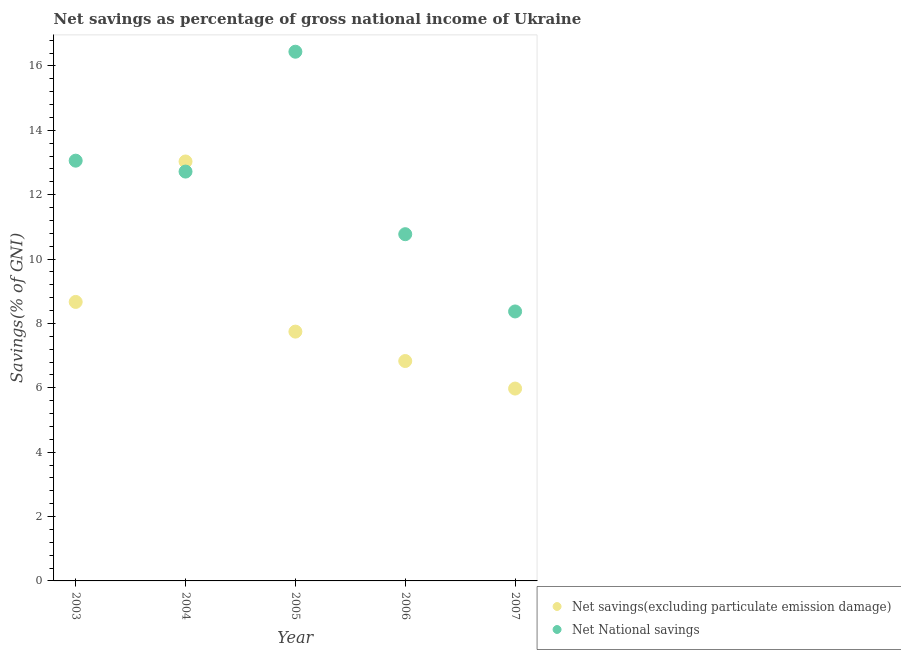How many different coloured dotlines are there?
Keep it short and to the point. 2. What is the net national savings in 2003?
Offer a very short reply. 13.06. Across all years, what is the maximum net savings(excluding particulate emission damage)?
Make the answer very short. 13.03. Across all years, what is the minimum net savings(excluding particulate emission damage)?
Provide a succinct answer. 5.98. What is the total net national savings in the graph?
Make the answer very short. 61.37. What is the difference between the net national savings in 2003 and that in 2006?
Keep it short and to the point. 2.28. What is the difference between the net savings(excluding particulate emission damage) in 2007 and the net national savings in 2005?
Offer a terse response. -10.47. What is the average net savings(excluding particulate emission damage) per year?
Your answer should be very brief. 8.45. In the year 2003, what is the difference between the net national savings and net savings(excluding particulate emission damage)?
Ensure brevity in your answer.  4.39. What is the ratio of the net savings(excluding particulate emission damage) in 2005 to that in 2006?
Ensure brevity in your answer.  1.13. Is the net savings(excluding particulate emission damage) in 2005 less than that in 2006?
Your answer should be very brief. No. Is the difference between the net savings(excluding particulate emission damage) in 2005 and 2007 greater than the difference between the net national savings in 2005 and 2007?
Ensure brevity in your answer.  No. What is the difference between the highest and the second highest net savings(excluding particulate emission damage)?
Your answer should be very brief. 4.36. What is the difference between the highest and the lowest net savings(excluding particulate emission damage)?
Ensure brevity in your answer.  7.06. In how many years, is the net savings(excluding particulate emission damage) greater than the average net savings(excluding particulate emission damage) taken over all years?
Give a very brief answer. 2. Is the net savings(excluding particulate emission damage) strictly less than the net national savings over the years?
Your response must be concise. No. How many dotlines are there?
Your response must be concise. 2. What is the difference between two consecutive major ticks on the Y-axis?
Your response must be concise. 2. Are the values on the major ticks of Y-axis written in scientific E-notation?
Offer a very short reply. No. Does the graph contain any zero values?
Offer a terse response. No. How are the legend labels stacked?
Offer a very short reply. Vertical. What is the title of the graph?
Offer a terse response. Net savings as percentage of gross national income of Ukraine. Does "Female entrants" appear as one of the legend labels in the graph?
Your answer should be compact. No. What is the label or title of the Y-axis?
Your answer should be compact. Savings(% of GNI). What is the Savings(% of GNI) of Net savings(excluding particulate emission damage) in 2003?
Ensure brevity in your answer.  8.67. What is the Savings(% of GNI) of Net National savings in 2003?
Make the answer very short. 13.06. What is the Savings(% of GNI) of Net savings(excluding particulate emission damage) in 2004?
Your answer should be very brief. 13.03. What is the Savings(% of GNI) in Net National savings in 2004?
Your answer should be compact. 12.72. What is the Savings(% of GNI) of Net savings(excluding particulate emission damage) in 2005?
Your answer should be very brief. 7.75. What is the Savings(% of GNI) of Net National savings in 2005?
Provide a succinct answer. 16.44. What is the Savings(% of GNI) in Net savings(excluding particulate emission damage) in 2006?
Ensure brevity in your answer.  6.83. What is the Savings(% of GNI) in Net National savings in 2006?
Offer a terse response. 10.77. What is the Savings(% of GNI) of Net savings(excluding particulate emission damage) in 2007?
Ensure brevity in your answer.  5.98. What is the Savings(% of GNI) of Net National savings in 2007?
Offer a terse response. 8.37. Across all years, what is the maximum Savings(% of GNI) of Net savings(excluding particulate emission damage)?
Offer a terse response. 13.03. Across all years, what is the maximum Savings(% of GNI) of Net National savings?
Your answer should be compact. 16.44. Across all years, what is the minimum Savings(% of GNI) of Net savings(excluding particulate emission damage)?
Your response must be concise. 5.98. Across all years, what is the minimum Savings(% of GNI) of Net National savings?
Ensure brevity in your answer.  8.37. What is the total Savings(% of GNI) in Net savings(excluding particulate emission damage) in the graph?
Your answer should be very brief. 42.26. What is the total Savings(% of GNI) of Net National savings in the graph?
Ensure brevity in your answer.  61.37. What is the difference between the Savings(% of GNI) in Net savings(excluding particulate emission damage) in 2003 and that in 2004?
Ensure brevity in your answer.  -4.36. What is the difference between the Savings(% of GNI) in Net National savings in 2003 and that in 2004?
Your answer should be compact. 0.34. What is the difference between the Savings(% of GNI) in Net savings(excluding particulate emission damage) in 2003 and that in 2005?
Your answer should be very brief. 0.92. What is the difference between the Savings(% of GNI) of Net National savings in 2003 and that in 2005?
Offer a terse response. -3.39. What is the difference between the Savings(% of GNI) of Net savings(excluding particulate emission damage) in 2003 and that in 2006?
Offer a very short reply. 1.84. What is the difference between the Savings(% of GNI) of Net National savings in 2003 and that in 2006?
Keep it short and to the point. 2.28. What is the difference between the Savings(% of GNI) in Net savings(excluding particulate emission damage) in 2003 and that in 2007?
Provide a succinct answer. 2.69. What is the difference between the Savings(% of GNI) of Net National savings in 2003 and that in 2007?
Your answer should be very brief. 4.69. What is the difference between the Savings(% of GNI) of Net savings(excluding particulate emission damage) in 2004 and that in 2005?
Your answer should be compact. 5.29. What is the difference between the Savings(% of GNI) in Net National savings in 2004 and that in 2005?
Your answer should be very brief. -3.72. What is the difference between the Savings(% of GNI) in Net savings(excluding particulate emission damage) in 2004 and that in 2006?
Give a very brief answer. 6.2. What is the difference between the Savings(% of GNI) in Net National savings in 2004 and that in 2006?
Make the answer very short. 1.95. What is the difference between the Savings(% of GNI) of Net savings(excluding particulate emission damage) in 2004 and that in 2007?
Make the answer very short. 7.06. What is the difference between the Savings(% of GNI) in Net National savings in 2004 and that in 2007?
Offer a very short reply. 4.35. What is the difference between the Savings(% of GNI) of Net savings(excluding particulate emission damage) in 2005 and that in 2006?
Offer a very short reply. 0.91. What is the difference between the Savings(% of GNI) in Net National savings in 2005 and that in 2006?
Your answer should be compact. 5.67. What is the difference between the Savings(% of GNI) of Net savings(excluding particulate emission damage) in 2005 and that in 2007?
Offer a very short reply. 1.77. What is the difference between the Savings(% of GNI) of Net National savings in 2005 and that in 2007?
Your answer should be compact. 8.07. What is the difference between the Savings(% of GNI) of Net savings(excluding particulate emission damage) in 2006 and that in 2007?
Your response must be concise. 0.86. What is the difference between the Savings(% of GNI) in Net National savings in 2006 and that in 2007?
Your response must be concise. 2.4. What is the difference between the Savings(% of GNI) in Net savings(excluding particulate emission damage) in 2003 and the Savings(% of GNI) in Net National savings in 2004?
Provide a short and direct response. -4.05. What is the difference between the Savings(% of GNI) of Net savings(excluding particulate emission damage) in 2003 and the Savings(% of GNI) of Net National savings in 2005?
Make the answer very short. -7.77. What is the difference between the Savings(% of GNI) of Net savings(excluding particulate emission damage) in 2003 and the Savings(% of GNI) of Net National savings in 2006?
Provide a short and direct response. -2.1. What is the difference between the Savings(% of GNI) of Net savings(excluding particulate emission damage) in 2003 and the Savings(% of GNI) of Net National savings in 2007?
Ensure brevity in your answer.  0.3. What is the difference between the Savings(% of GNI) of Net savings(excluding particulate emission damage) in 2004 and the Savings(% of GNI) of Net National savings in 2005?
Offer a terse response. -3.41. What is the difference between the Savings(% of GNI) of Net savings(excluding particulate emission damage) in 2004 and the Savings(% of GNI) of Net National savings in 2006?
Make the answer very short. 2.26. What is the difference between the Savings(% of GNI) of Net savings(excluding particulate emission damage) in 2004 and the Savings(% of GNI) of Net National savings in 2007?
Give a very brief answer. 4.66. What is the difference between the Savings(% of GNI) of Net savings(excluding particulate emission damage) in 2005 and the Savings(% of GNI) of Net National savings in 2006?
Your answer should be very brief. -3.03. What is the difference between the Savings(% of GNI) in Net savings(excluding particulate emission damage) in 2005 and the Savings(% of GNI) in Net National savings in 2007?
Your answer should be compact. -0.63. What is the difference between the Savings(% of GNI) in Net savings(excluding particulate emission damage) in 2006 and the Savings(% of GNI) in Net National savings in 2007?
Provide a succinct answer. -1.54. What is the average Savings(% of GNI) of Net savings(excluding particulate emission damage) per year?
Give a very brief answer. 8.45. What is the average Savings(% of GNI) in Net National savings per year?
Your answer should be compact. 12.27. In the year 2003, what is the difference between the Savings(% of GNI) of Net savings(excluding particulate emission damage) and Savings(% of GNI) of Net National savings?
Offer a terse response. -4.39. In the year 2004, what is the difference between the Savings(% of GNI) of Net savings(excluding particulate emission damage) and Savings(% of GNI) of Net National savings?
Your answer should be compact. 0.31. In the year 2005, what is the difference between the Savings(% of GNI) in Net savings(excluding particulate emission damage) and Savings(% of GNI) in Net National savings?
Keep it short and to the point. -8.7. In the year 2006, what is the difference between the Savings(% of GNI) of Net savings(excluding particulate emission damage) and Savings(% of GNI) of Net National savings?
Make the answer very short. -3.94. In the year 2007, what is the difference between the Savings(% of GNI) in Net savings(excluding particulate emission damage) and Savings(% of GNI) in Net National savings?
Your answer should be compact. -2.4. What is the ratio of the Savings(% of GNI) in Net savings(excluding particulate emission damage) in 2003 to that in 2004?
Ensure brevity in your answer.  0.67. What is the ratio of the Savings(% of GNI) of Net National savings in 2003 to that in 2004?
Ensure brevity in your answer.  1.03. What is the ratio of the Savings(% of GNI) of Net savings(excluding particulate emission damage) in 2003 to that in 2005?
Your answer should be very brief. 1.12. What is the ratio of the Savings(% of GNI) in Net National savings in 2003 to that in 2005?
Give a very brief answer. 0.79. What is the ratio of the Savings(% of GNI) in Net savings(excluding particulate emission damage) in 2003 to that in 2006?
Ensure brevity in your answer.  1.27. What is the ratio of the Savings(% of GNI) in Net National savings in 2003 to that in 2006?
Provide a short and direct response. 1.21. What is the ratio of the Savings(% of GNI) in Net savings(excluding particulate emission damage) in 2003 to that in 2007?
Provide a short and direct response. 1.45. What is the ratio of the Savings(% of GNI) of Net National savings in 2003 to that in 2007?
Offer a terse response. 1.56. What is the ratio of the Savings(% of GNI) of Net savings(excluding particulate emission damage) in 2004 to that in 2005?
Make the answer very short. 1.68. What is the ratio of the Savings(% of GNI) in Net National savings in 2004 to that in 2005?
Your answer should be compact. 0.77. What is the ratio of the Savings(% of GNI) in Net savings(excluding particulate emission damage) in 2004 to that in 2006?
Ensure brevity in your answer.  1.91. What is the ratio of the Savings(% of GNI) in Net National savings in 2004 to that in 2006?
Your answer should be very brief. 1.18. What is the ratio of the Savings(% of GNI) in Net savings(excluding particulate emission damage) in 2004 to that in 2007?
Your answer should be compact. 2.18. What is the ratio of the Savings(% of GNI) of Net National savings in 2004 to that in 2007?
Offer a very short reply. 1.52. What is the ratio of the Savings(% of GNI) of Net savings(excluding particulate emission damage) in 2005 to that in 2006?
Provide a succinct answer. 1.13. What is the ratio of the Savings(% of GNI) in Net National savings in 2005 to that in 2006?
Your answer should be very brief. 1.53. What is the ratio of the Savings(% of GNI) in Net savings(excluding particulate emission damage) in 2005 to that in 2007?
Your response must be concise. 1.3. What is the ratio of the Savings(% of GNI) of Net National savings in 2005 to that in 2007?
Offer a very short reply. 1.96. What is the ratio of the Savings(% of GNI) of Net savings(excluding particulate emission damage) in 2006 to that in 2007?
Make the answer very short. 1.14. What is the ratio of the Savings(% of GNI) in Net National savings in 2006 to that in 2007?
Provide a succinct answer. 1.29. What is the difference between the highest and the second highest Savings(% of GNI) of Net savings(excluding particulate emission damage)?
Provide a short and direct response. 4.36. What is the difference between the highest and the second highest Savings(% of GNI) of Net National savings?
Keep it short and to the point. 3.39. What is the difference between the highest and the lowest Savings(% of GNI) of Net savings(excluding particulate emission damage)?
Give a very brief answer. 7.06. What is the difference between the highest and the lowest Savings(% of GNI) of Net National savings?
Provide a short and direct response. 8.07. 